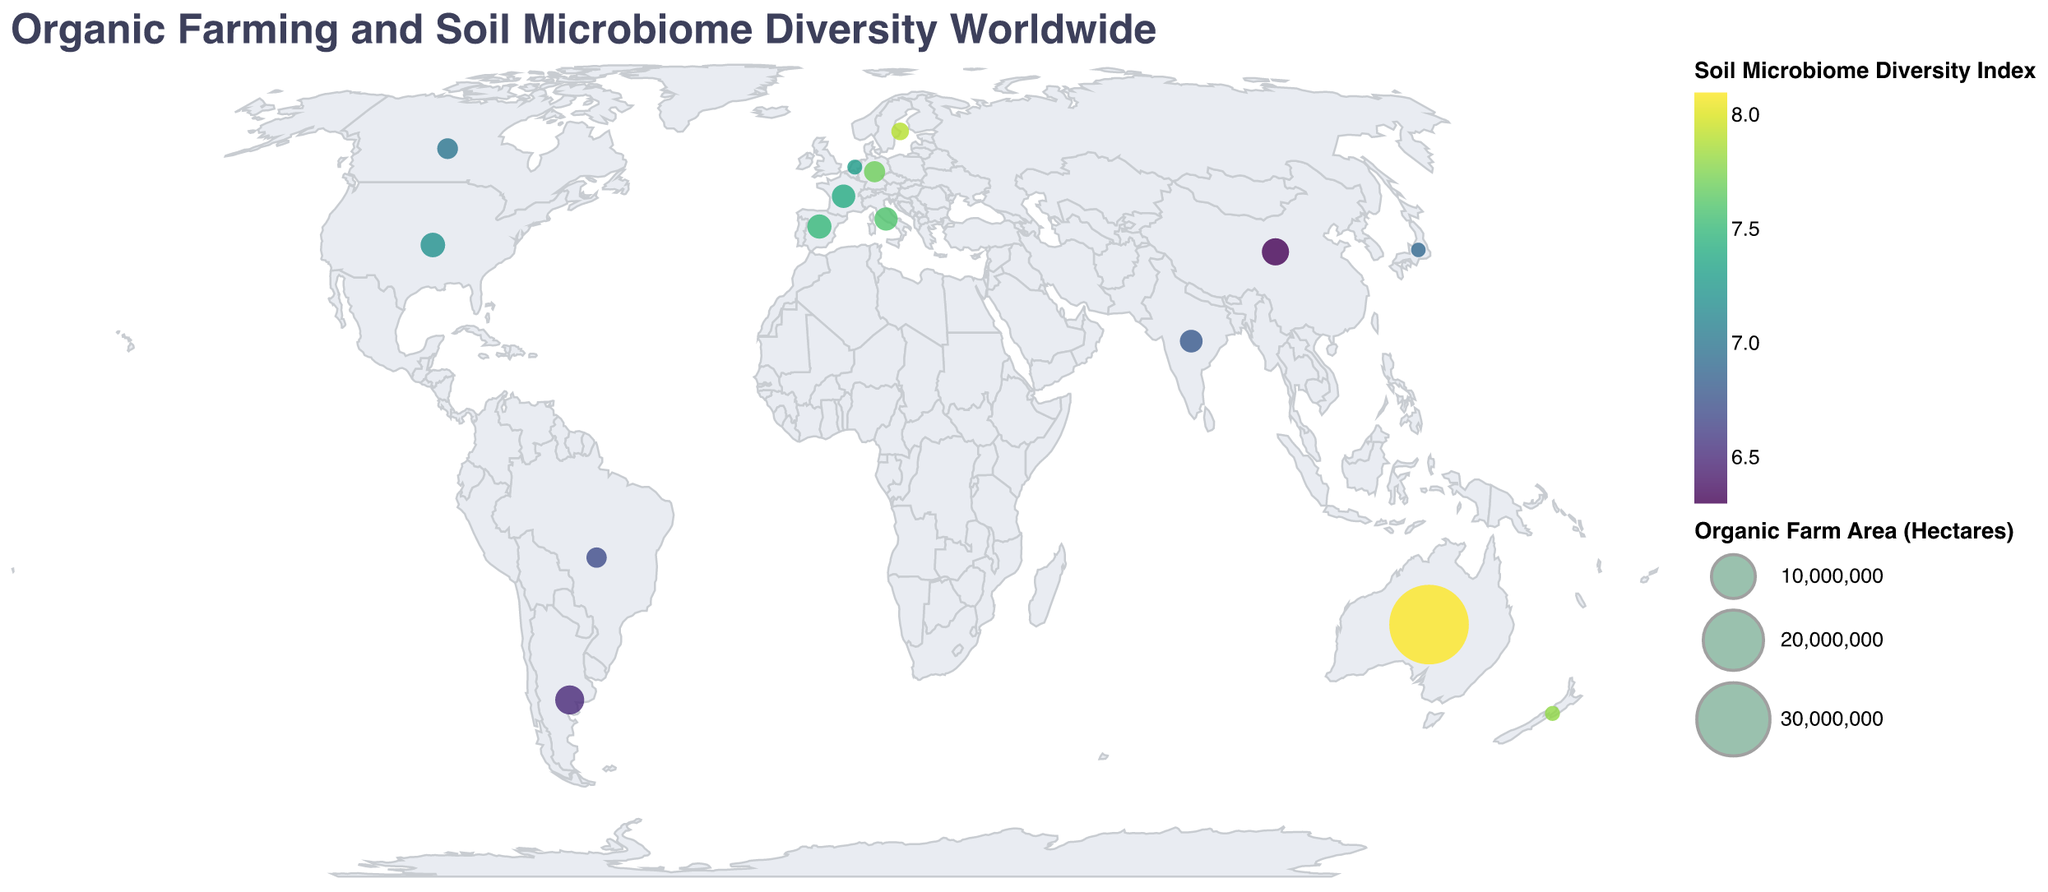What is the country with the highest Soil Microbiome Diversity Index? The highest Soil Microbiome Diversity Index is represented by the darkest color in the color legend. Based on the figure, Australia has the highest Index value of 8.1.
Answer: Australia Which country has the largest area of organic farm land? The largest area of organic farm land is indicated by the largest circle in the plot. Australia has the largest organic farm area with 35,700,000 hectares.
Answer: Australia Which farming practice is most dominant in Germany? For each country, the tooltip provides the dominant farming practice. In the case of Germany, the dominant farming practice is Cover cropping.
Answer: Cover cropping Compare the Soil Microbiome Diversity Index between the USA and Germany. Which one is higher? The Soil Microbiome Diversity Index for the USA is 7.2, and for Germany, it is 7.7. Therefore, Germany has a higher Soil Microbiome Diversity Index than the USA.
Answer: Germany What is the average Soil Microbiome Diversity Index of countries with organic farm areas over 2 million hectares? The countries with over 2 million hectares are USA, India, Spain, Australia, Argentina, and China. Their respective Soil Microbiome Diversity Index values are 7.2, 6.8, 7.5, 8.1, 6.5, and 6.3. Sum these values (7.2 + 6.8 + 7.5 + 8.1 + 6.5 + 6.3 = 42.4) and divide by the number of countries (42.4 / 6).
Answer: 7.07 In which country is Polyculture the dominant farming practice? The tooltip for each country lists the dominant farming practice. In Japan, the dominant practice is Polyculture.
Answer: Japan Which country has the smallest organic farm area, and what is its Soil Microbiome Diversity Index? The smallest organic farm area is represented by the smallest circle in the plot, which is Japan with 10,000 hectares. The Soil Microbiome Diversity Index for Japan is 6.9.
Answer: Japan, 6.9 What is the difference in the Soil Microbiome Diversity Index between Spain and Brazil? Spain has a Soil Microbiome Diversity Index of 7.5, while Brazil's index is 6.7. The difference between them is 7.5 - 6.7.
Answer: 0.8 Rank the countries based on their Soil Microbiome Diversity Index in descending order. List the Soil Microbiome Diversity Index of each country and sort them from highest to lowest: Australia (8.1), Sweden (7.9), New Zealand (7.8), Germany (7.7), Italy (7.6), Spain (7.5), France (7.4), Netherlands (7.3), USA (7.2), Canada (7.0), Japan (6.9), India (6.8), Brazil (6.7), Argentina (6.5), China (6.3).
Answer: Australia, Sweden, New Zealand, Germany, Italy, Spain, France, Netherlands, USA, Canada, Japan, India, Brazil, Argentina, China Which country utilizes Precision farming, and what is its Soil Microbiome Diversity Index value? According to the tooltip, Precision farming is the dominant practice in the Netherlands, which has a Soil Microbiome Diversity Index of 7.3.
Answer: Netherlands, 7.3 